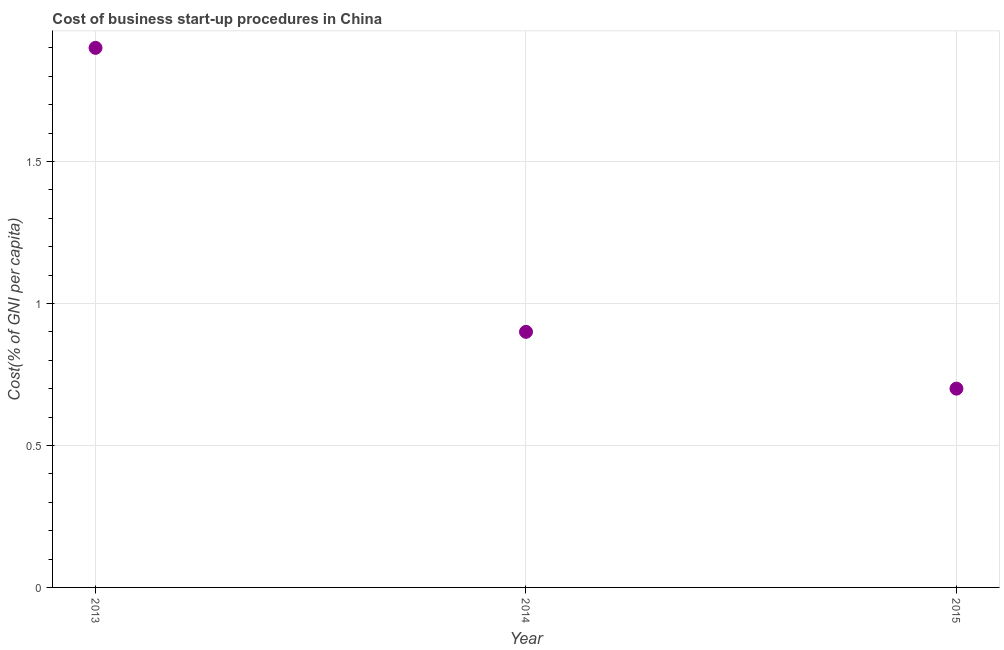Across all years, what is the maximum cost of business startup procedures?
Make the answer very short. 1.9. In which year was the cost of business startup procedures minimum?
Offer a terse response. 2015. What is the sum of the cost of business startup procedures?
Offer a terse response. 3.5. What is the difference between the cost of business startup procedures in 2014 and 2015?
Provide a succinct answer. 0.2. What is the average cost of business startup procedures per year?
Keep it short and to the point. 1.17. What is the ratio of the cost of business startup procedures in 2013 to that in 2014?
Make the answer very short. 2.11. Is the difference between the cost of business startup procedures in 2013 and 2015 greater than the difference between any two years?
Provide a succinct answer. Yes. What is the difference between the highest and the second highest cost of business startup procedures?
Make the answer very short. 1. What is the difference between the highest and the lowest cost of business startup procedures?
Ensure brevity in your answer.  1.2. Does the cost of business startup procedures monotonically increase over the years?
Offer a very short reply. No. How many years are there in the graph?
Keep it short and to the point. 3. Are the values on the major ticks of Y-axis written in scientific E-notation?
Make the answer very short. No. What is the title of the graph?
Your answer should be compact. Cost of business start-up procedures in China. What is the label or title of the Y-axis?
Your answer should be very brief. Cost(% of GNI per capita). What is the Cost(% of GNI per capita) in 2013?
Offer a terse response. 1.9. What is the Cost(% of GNI per capita) in 2015?
Ensure brevity in your answer.  0.7. What is the difference between the Cost(% of GNI per capita) in 2013 and 2014?
Offer a very short reply. 1. What is the ratio of the Cost(% of GNI per capita) in 2013 to that in 2014?
Provide a short and direct response. 2.11. What is the ratio of the Cost(% of GNI per capita) in 2013 to that in 2015?
Offer a terse response. 2.71. What is the ratio of the Cost(% of GNI per capita) in 2014 to that in 2015?
Provide a short and direct response. 1.29. 